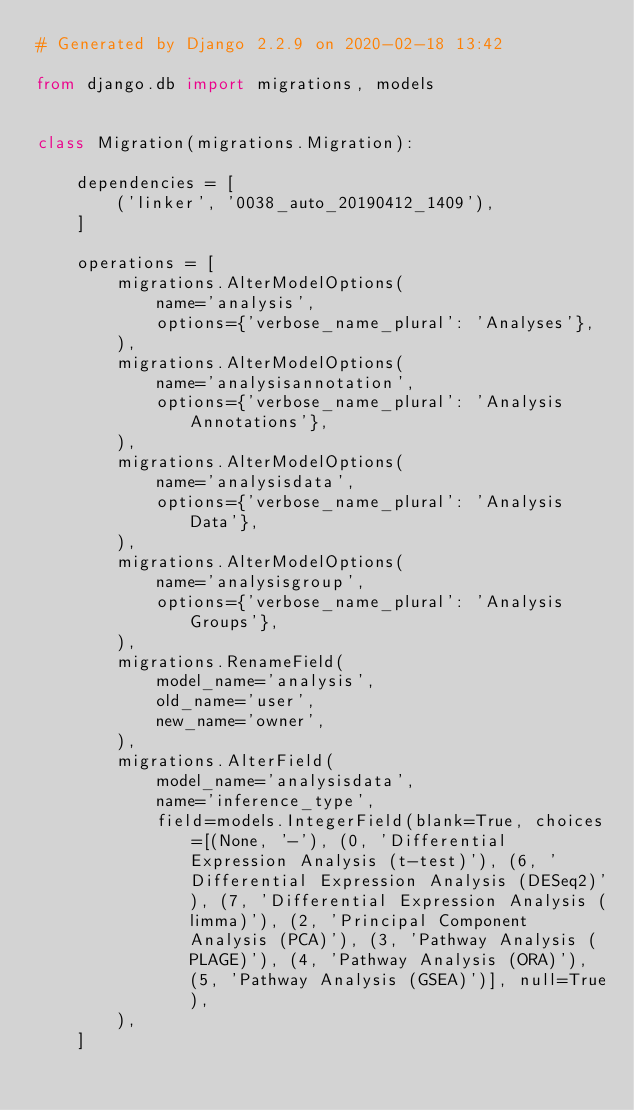<code> <loc_0><loc_0><loc_500><loc_500><_Python_># Generated by Django 2.2.9 on 2020-02-18 13:42

from django.db import migrations, models


class Migration(migrations.Migration):

    dependencies = [
        ('linker', '0038_auto_20190412_1409'),
    ]

    operations = [
        migrations.AlterModelOptions(
            name='analysis',
            options={'verbose_name_plural': 'Analyses'},
        ),
        migrations.AlterModelOptions(
            name='analysisannotation',
            options={'verbose_name_plural': 'Analysis Annotations'},
        ),
        migrations.AlterModelOptions(
            name='analysisdata',
            options={'verbose_name_plural': 'Analysis Data'},
        ),
        migrations.AlterModelOptions(
            name='analysisgroup',
            options={'verbose_name_plural': 'Analysis Groups'},
        ),
        migrations.RenameField(
            model_name='analysis',
            old_name='user',
            new_name='owner',
        ),
        migrations.AlterField(
            model_name='analysisdata',
            name='inference_type',
            field=models.IntegerField(blank=True, choices=[(None, '-'), (0, 'Differential Expression Analysis (t-test)'), (6, 'Differential Expression Analysis (DESeq2)'), (7, 'Differential Expression Analysis (limma)'), (2, 'Principal Component Analysis (PCA)'), (3, 'Pathway Analysis (PLAGE)'), (4, 'Pathway Analysis (ORA)'), (5, 'Pathway Analysis (GSEA)')], null=True),
        ),
    ]
</code> 